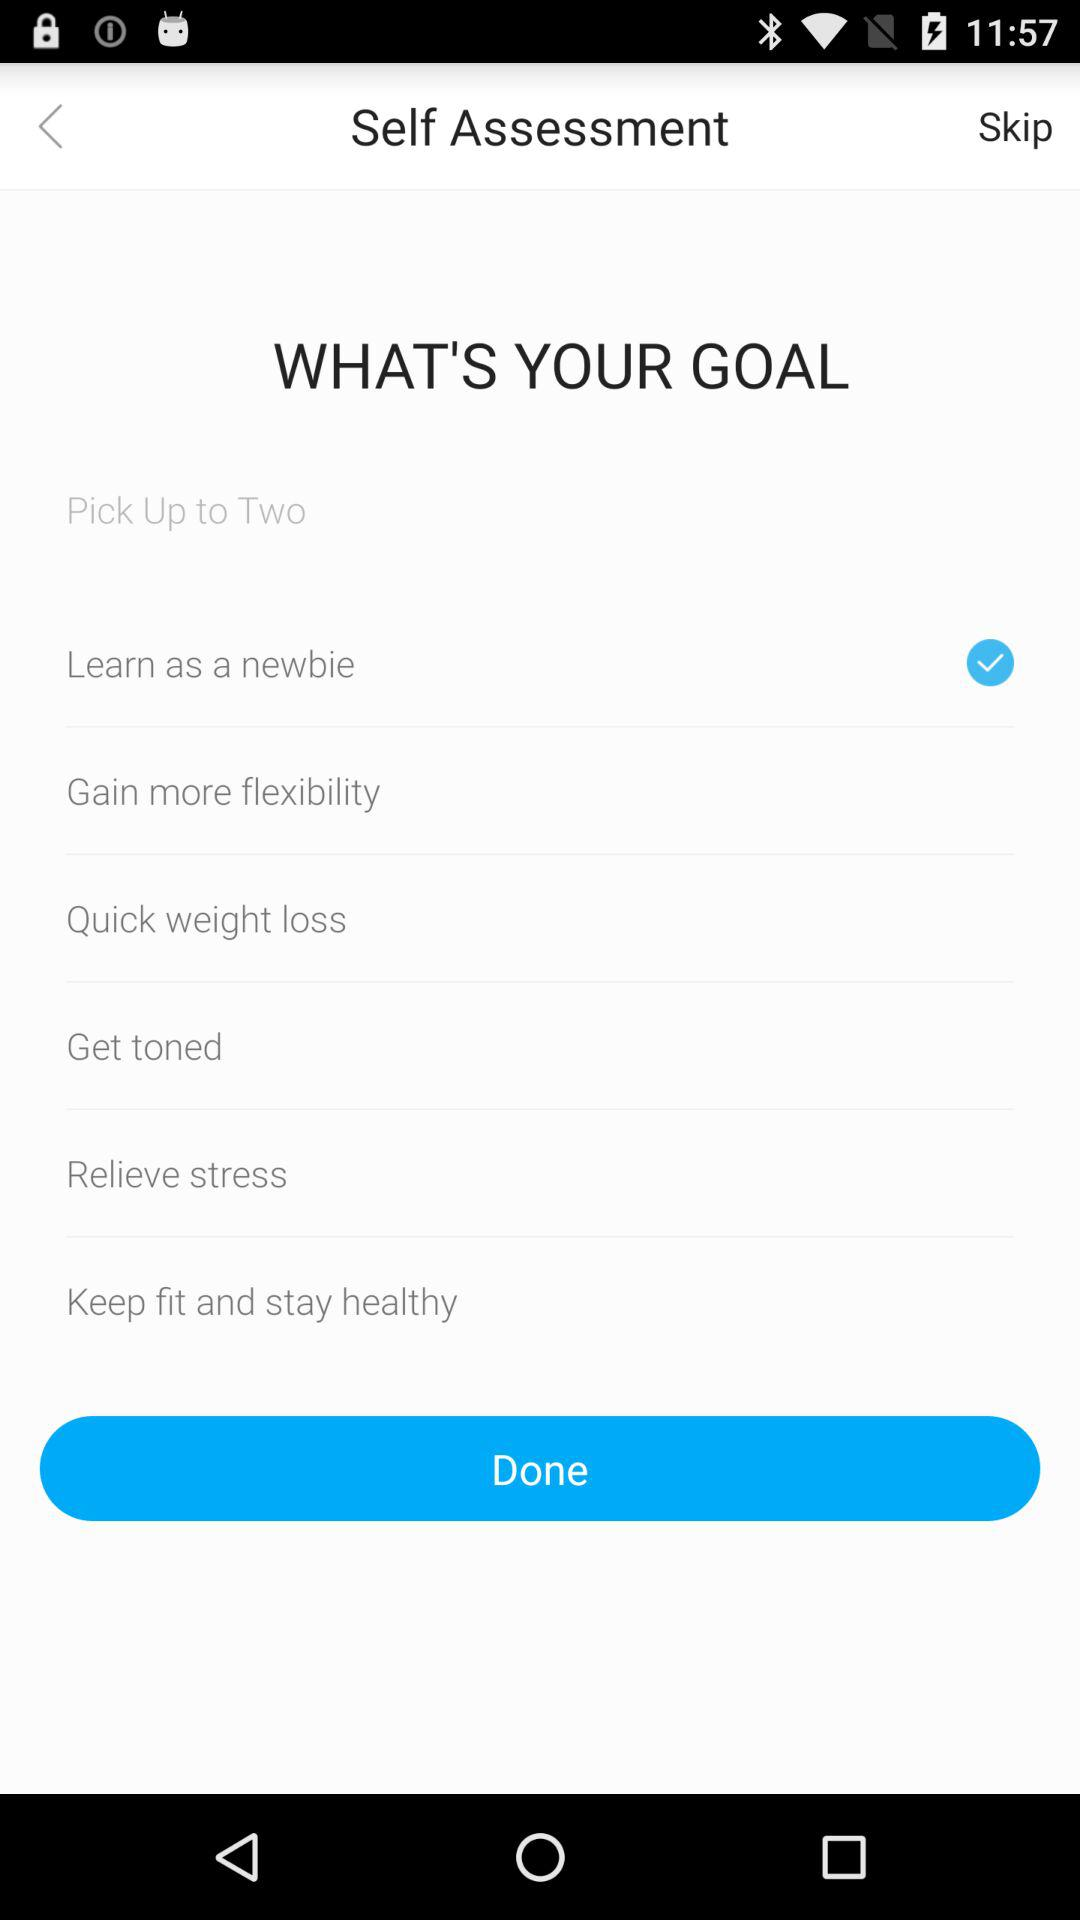How many goals are there that are not about weight loss?
Answer the question using a single word or phrase. 4 